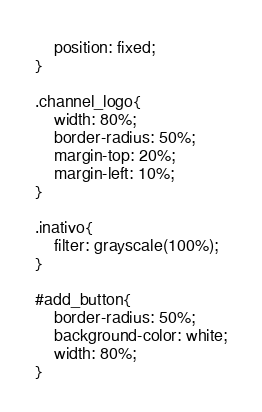<code> <loc_0><loc_0><loc_500><loc_500><_CSS_>	position: fixed;
}

.channel_logo{
	width: 80%;
	border-radius: 50%;
	margin-top: 20%;
	margin-left: 10%;
}

.inativo{
	filter: grayscale(100%);
}

#add_button{
	border-radius: 50%;
	background-color: white;
	width: 80%;
}</code> 